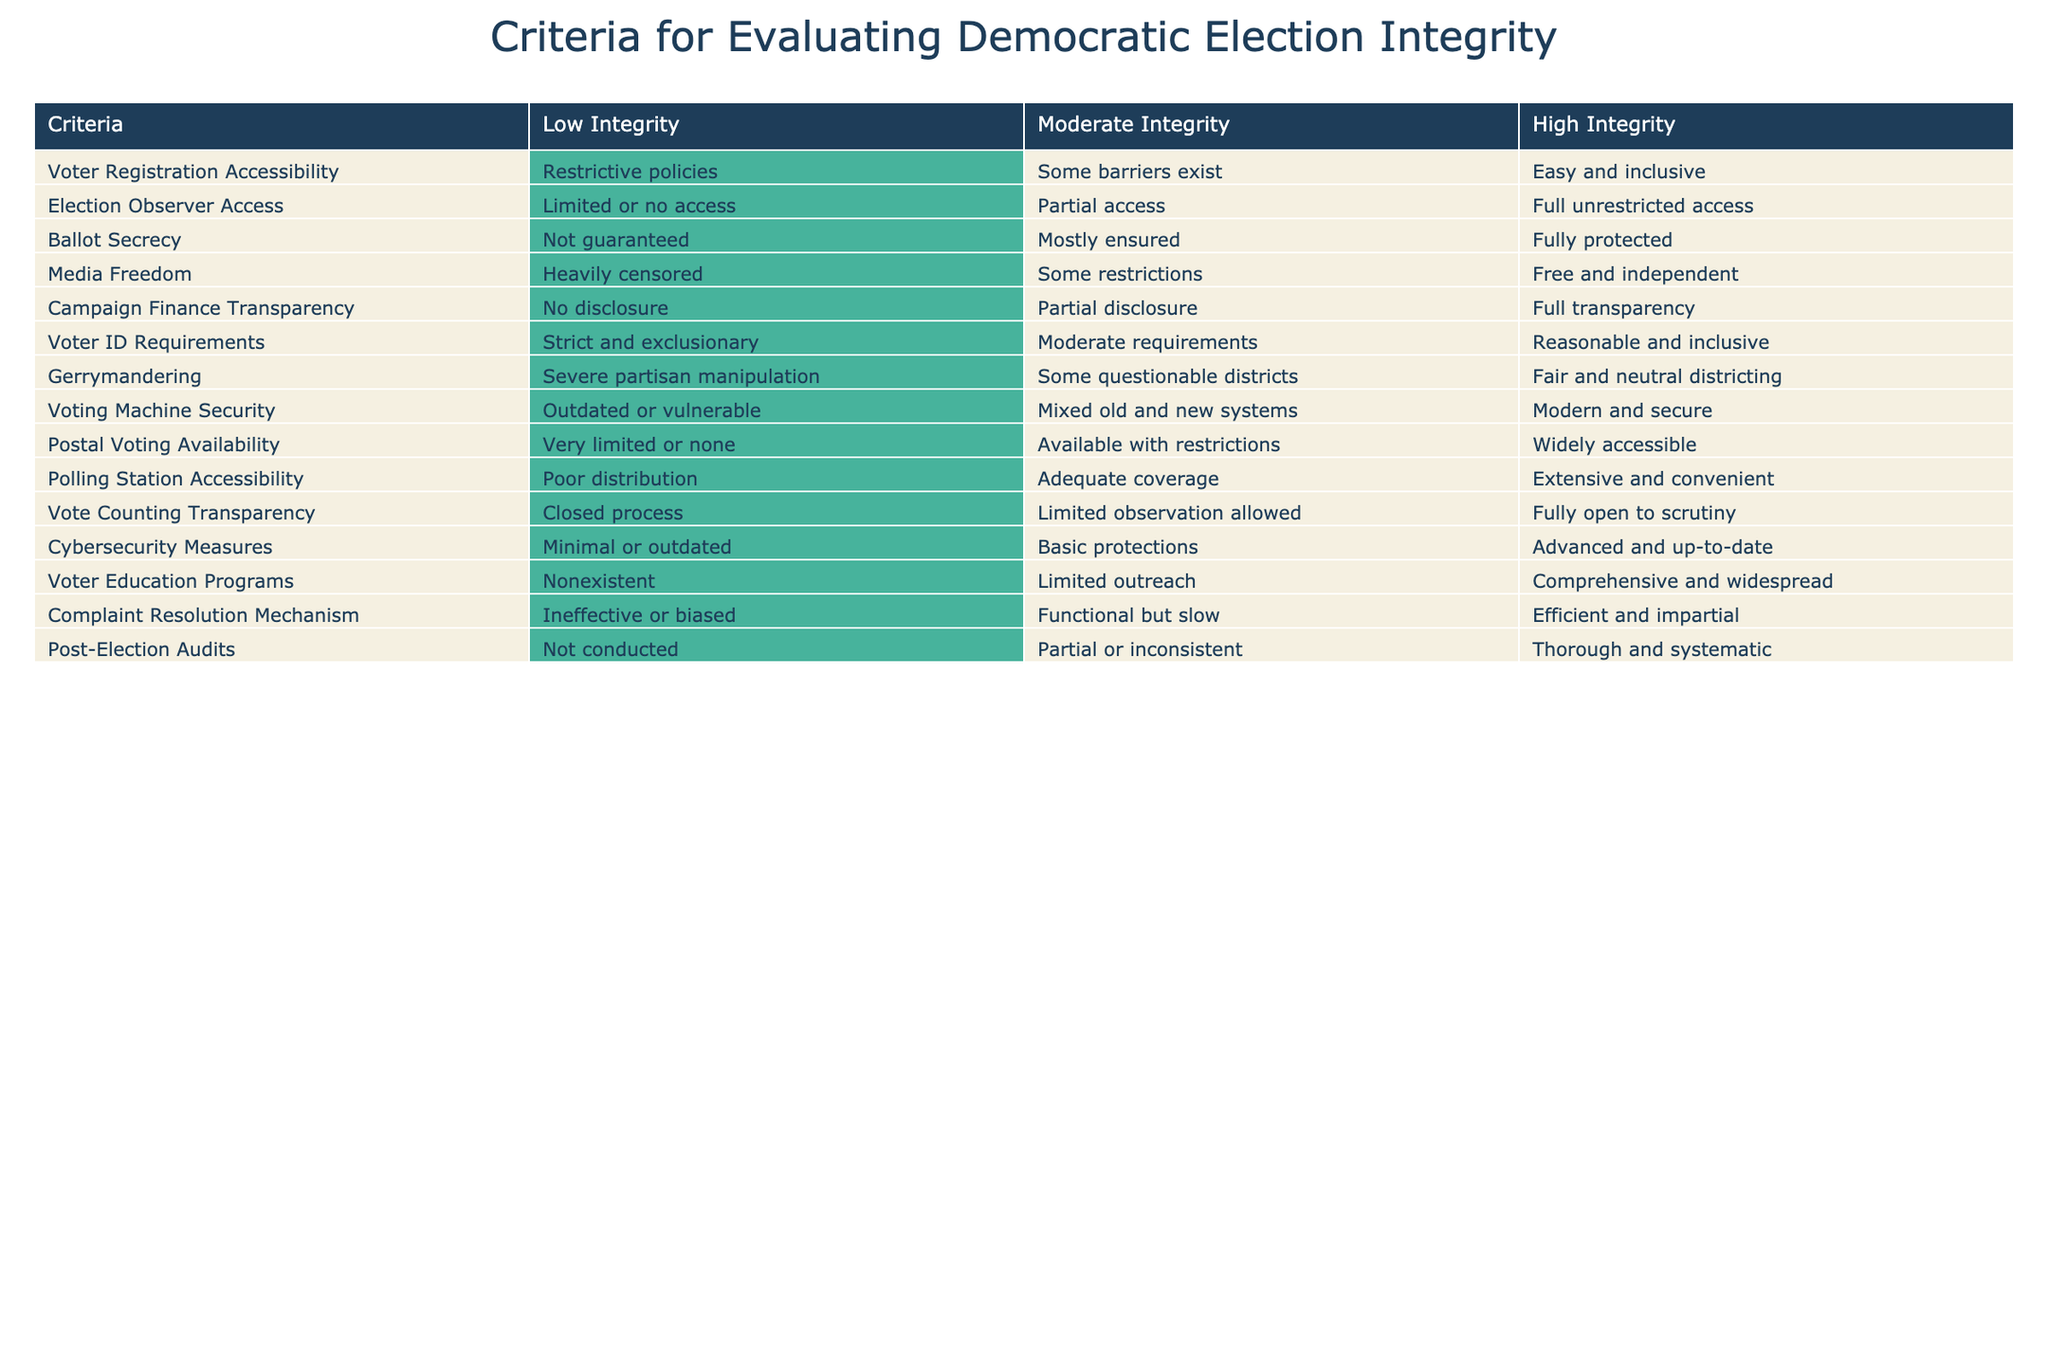What is the condition of voter registration accessibility in a high integrity election? The table states that in a high integrity election, voter registration accessibility is described as "Easy and inclusive." This is directly referenced in the row for Voter Registration Accessibility under the "High Integrity" column.
Answer: Easy and inclusive What are the criteria under which ballot secrecy is mostly ensured? The table indicates that "Mostly ensured" for ballot secrecy falls under the "Moderate Integrity" category. This means that there are still some concerns regarding ballot secrecy that prevent it from being fully protected.
Answer: Moderate Integrity Is it true that gerrymandering is fair in a high integrity election? According to the table, in a high integrity election, gerrymandering is categorized as "Fair and neutral districting." Thus, it is accurate to say that gerrymandering is fair when the integrity is high.
Answer: Yes How many criteria indicate low integrity in voter ID requirements? From the table, there is one criteria listed for low integrity describing voter ID requirements as "Strict and exclusionary." This is directly found in the row for Voter ID Requirements under the "Low Integrity" column.
Answer: One What is the difference between the conditions of voting machine security between moderate and high integrity? The table states that voting machine security in a moderate integrity election is characterized as "Mixed old and new systems" while in a high integrity election it is "Modern and secure." The difference is that modern systems offer better security compared to a mix of old and new ones.
Answer: Modern vs. Mixed In terms of media freedom, how does low integrity compare to high integrity situations? According to the table, media freedom is "Heavily censored" in low integrity and "Free and independent" in high integrity. This shows a stark contrast in the freedom experienced by media under these two integrity conditions, highlighting the drastic differences in regulation and freedom of press.
Answer: Heavily censored vs. Free and independent What is the average condition of accessibility for polling stations across the integrity ratings? Polling station accessibility is categorized as "Poor distribution" in low integrity, "Adequate coverage" in moderate integrity, and "Extensive and convenient" in high integrity. Converting these qualitative descriptions into numerical scores (1 for low, 2 for moderate, and 3 for high), the average is calculated as (1 + 2 + 3)/3 = 2. Therefore, the average condition is moderate.
Answer: Moderate Are there any specific criteria where cybersecurity measures are minimum or outdated? The table qualifies some cybersecurity measures as "Minimal or outdated" under the low integrity category. This indicates that in situations rated for low integrity, cybersecurity is lacking.
Answer: Yes How would you summarize the presence of complaint resolution mechanisms in elections with high integrity? The table shows that in high integrity elections, complaint resolution mechanisms are "Efficient and impartial," suggesting that there is a robust process for addressing grievances and issues related to the election process under high integrity conditions.
Answer: Efficient and impartial 